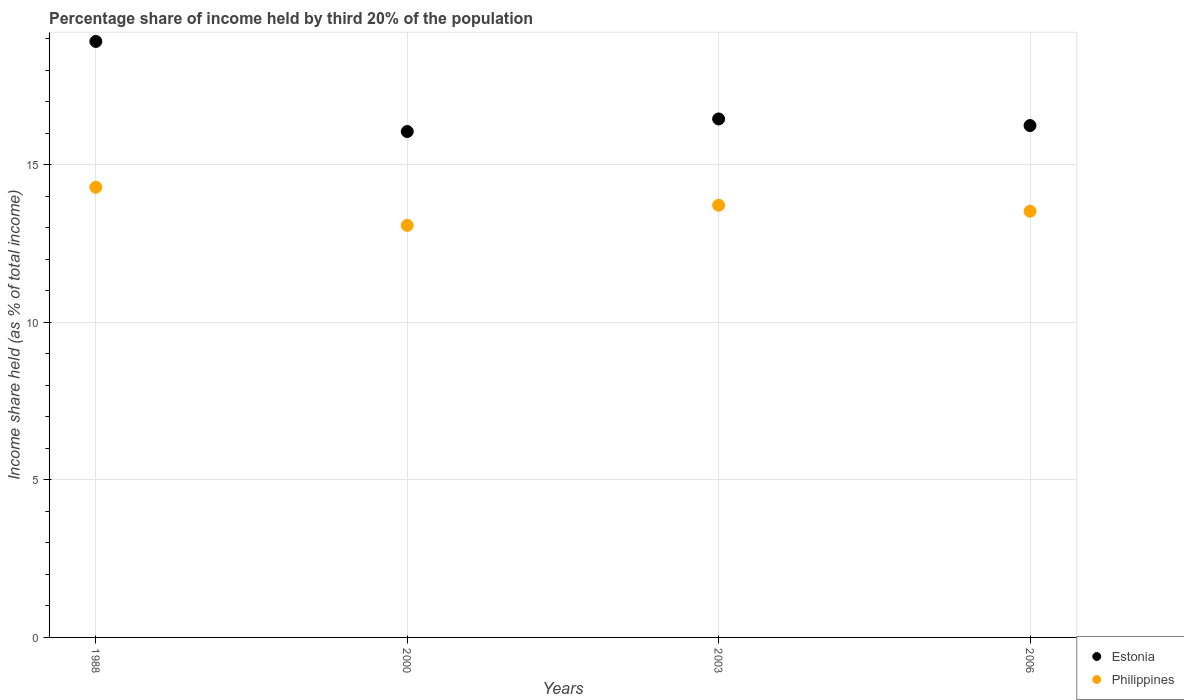How many different coloured dotlines are there?
Offer a very short reply. 2. What is the share of income held by third 20% of the population in Philippines in 2000?
Your answer should be very brief. 13.08. Across all years, what is the maximum share of income held by third 20% of the population in Philippines?
Provide a short and direct response. 14.29. Across all years, what is the minimum share of income held by third 20% of the population in Estonia?
Your answer should be compact. 16.06. In which year was the share of income held by third 20% of the population in Estonia minimum?
Offer a terse response. 2000. What is the total share of income held by third 20% of the population in Estonia in the graph?
Make the answer very short. 67.69. What is the difference between the share of income held by third 20% of the population in Philippines in 1988 and that in 2000?
Provide a short and direct response. 1.21. What is the difference between the share of income held by third 20% of the population in Philippines in 2006 and the share of income held by third 20% of the population in Estonia in 1988?
Offer a very short reply. -5.39. What is the average share of income held by third 20% of the population in Estonia per year?
Your answer should be very brief. 16.92. In the year 2003, what is the difference between the share of income held by third 20% of the population in Philippines and share of income held by third 20% of the population in Estonia?
Offer a very short reply. -2.74. What is the ratio of the share of income held by third 20% of the population in Estonia in 1988 to that in 2003?
Offer a terse response. 1.15. Is the difference between the share of income held by third 20% of the population in Philippines in 1988 and 2000 greater than the difference between the share of income held by third 20% of the population in Estonia in 1988 and 2000?
Ensure brevity in your answer.  No. What is the difference between the highest and the second highest share of income held by third 20% of the population in Estonia?
Your answer should be very brief. 2.46. What is the difference between the highest and the lowest share of income held by third 20% of the population in Philippines?
Ensure brevity in your answer.  1.21. In how many years, is the share of income held by third 20% of the population in Estonia greater than the average share of income held by third 20% of the population in Estonia taken over all years?
Your answer should be compact. 1. Is the sum of the share of income held by third 20% of the population in Estonia in 2000 and 2006 greater than the maximum share of income held by third 20% of the population in Philippines across all years?
Keep it short and to the point. Yes. Does the share of income held by third 20% of the population in Estonia monotonically increase over the years?
Provide a short and direct response. No. Is the share of income held by third 20% of the population in Philippines strictly greater than the share of income held by third 20% of the population in Estonia over the years?
Make the answer very short. No. How many years are there in the graph?
Provide a short and direct response. 4. Are the values on the major ticks of Y-axis written in scientific E-notation?
Keep it short and to the point. No. How many legend labels are there?
Provide a short and direct response. 2. How are the legend labels stacked?
Provide a short and direct response. Vertical. What is the title of the graph?
Your response must be concise. Percentage share of income held by third 20% of the population. What is the label or title of the Y-axis?
Your answer should be very brief. Income share held (as % of total income). What is the Income share held (as % of total income) of Estonia in 1988?
Your answer should be very brief. 18.92. What is the Income share held (as % of total income) in Philippines in 1988?
Keep it short and to the point. 14.29. What is the Income share held (as % of total income) of Estonia in 2000?
Your response must be concise. 16.06. What is the Income share held (as % of total income) of Philippines in 2000?
Provide a short and direct response. 13.08. What is the Income share held (as % of total income) of Estonia in 2003?
Keep it short and to the point. 16.46. What is the Income share held (as % of total income) of Philippines in 2003?
Ensure brevity in your answer.  13.72. What is the Income share held (as % of total income) in Estonia in 2006?
Provide a short and direct response. 16.25. What is the Income share held (as % of total income) of Philippines in 2006?
Keep it short and to the point. 13.53. Across all years, what is the maximum Income share held (as % of total income) of Estonia?
Give a very brief answer. 18.92. Across all years, what is the maximum Income share held (as % of total income) in Philippines?
Give a very brief answer. 14.29. Across all years, what is the minimum Income share held (as % of total income) of Estonia?
Provide a succinct answer. 16.06. Across all years, what is the minimum Income share held (as % of total income) of Philippines?
Ensure brevity in your answer.  13.08. What is the total Income share held (as % of total income) in Estonia in the graph?
Ensure brevity in your answer.  67.69. What is the total Income share held (as % of total income) in Philippines in the graph?
Offer a terse response. 54.62. What is the difference between the Income share held (as % of total income) of Estonia in 1988 and that in 2000?
Keep it short and to the point. 2.86. What is the difference between the Income share held (as % of total income) of Philippines in 1988 and that in 2000?
Your response must be concise. 1.21. What is the difference between the Income share held (as % of total income) in Estonia in 1988 and that in 2003?
Your response must be concise. 2.46. What is the difference between the Income share held (as % of total income) in Philippines in 1988 and that in 2003?
Offer a terse response. 0.57. What is the difference between the Income share held (as % of total income) in Estonia in 1988 and that in 2006?
Provide a succinct answer. 2.67. What is the difference between the Income share held (as % of total income) of Philippines in 1988 and that in 2006?
Offer a terse response. 0.76. What is the difference between the Income share held (as % of total income) in Estonia in 2000 and that in 2003?
Provide a succinct answer. -0.4. What is the difference between the Income share held (as % of total income) of Philippines in 2000 and that in 2003?
Give a very brief answer. -0.64. What is the difference between the Income share held (as % of total income) of Estonia in 2000 and that in 2006?
Keep it short and to the point. -0.19. What is the difference between the Income share held (as % of total income) of Philippines in 2000 and that in 2006?
Give a very brief answer. -0.45. What is the difference between the Income share held (as % of total income) of Estonia in 2003 and that in 2006?
Keep it short and to the point. 0.21. What is the difference between the Income share held (as % of total income) in Philippines in 2003 and that in 2006?
Ensure brevity in your answer.  0.19. What is the difference between the Income share held (as % of total income) of Estonia in 1988 and the Income share held (as % of total income) of Philippines in 2000?
Offer a terse response. 5.84. What is the difference between the Income share held (as % of total income) of Estonia in 1988 and the Income share held (as % of total income) of Philippines in 2003?
Give a very brief answer. 5.2. What is the difference between the Income share held (as % of total income) in Estonia in 1988 and the Income share held (as % of total income) in Philippines in 2006?
Offer a terse response. 5.39. What is the difference between the Income share held (as % of total income) in Estonia in 2000 and the Income share held (as % of total income) in Philippines in 2003?
Your answer should be very brief. 2.34. What is the difference between the Income share held (as % of total income) in Estonia in 2000 and the Income share held (as % of total income) in Philippines in 2006?
Offer a terse response. 2.53. What is the difference between the Income share held (as % of total income) in Estonia in 2003 and the Income share held (as % of total income) in Philippines in 2006?
Offer a very short reply. 2.93. What is the average Income share held (as % of total income) in Estonia per year?
Offer a very short reply. 16.92. What is the average Income share held (as % of total income) of Philippines per year?
Provide a short and direct response. 13.65. In the year 1988, what is the difference between the Income share held (as % of total income) in Estonia and Income share held (as % of total income) in Philippines?
Give a very brief answer. 4.63. In the year 2000, what is the difference between the Income share held (as % of total income) of Estonia and Income share held (as % of total income) of Philippines?
Your response must be concise. 2.98. In the year 2003, what is the difference between the Income share held (as % of total income) in Estonia and Income share held (as % of total income) in Philippines?
Keep it short and to the point. 2.74. In the year 2006, what is the difference between the Income share held (as % of total income) of Estonia and Income share held (as % of total income) of Philippines?
Make the answer very short. 2.72. What is the ratio of the Income share held (as % of total income) in Estonia in 1988 to that in 2000?
Give a very brief answer. 1.18. What is the ratio of the Income share held (as % of total income) of Philippines in 1988 to that in 2000?
Give a very brief answer. 1.09. What is the ratio of the Income share held (as % of total income) of Estonia in 1988 to that in 2003?
Make the answer very short. 1.15. What is the ratio of the Income share held (as % of total income) in Philippines in 1988 to that in 2003?
Make the answer very short. 1.04. What is the ratio of the Income share held (as % of total income) of Estonia in 1988 to that in 2006?
Offer a very short reply. 1.16. What is the ratio of the Income share held (as % of total income) of Philippines in 1988 to that in 2006?
Offer a terse response. 1.06. What is the ratio of the Income share held (as % of total income) in Estonia in 2000 to that in 2003?
Your answer should be compact. 0.98. What is the ratio of the Income share held (as % of total income) of Philippines in 2000 to that in 2003?
Your answer should be very brief. 0.95. What is the ratio of the Income share held (as % of total income) of Estonia in 2000 to that in 2006?
Give a very brief answer. 0.99. What is the ratio of the Income share held (as % of total income) in Philippines in 2000 to that in 2006?
Offer a very short reply. 0.97. What is the ratio of the Income share held (as % of total income) of Estonia in 2003 to that in 2006?
Offer a very short reply. 1.01. What is the difference between the highest and the second highest Income share held (as % of total income) in Estonia?
Provide a short and direct response. 2.46. What is the difference between the highest and the second highest Income share held (as % of total income) in Philippines?
Provide a short and direct response. 0.57. What is the difference between the highest and the lowest Income share held (as % of total income) of Estonia?
Your answer should be very brief. 2.86. What is the difference between the highest and the lowest Income share held (as % of total income) in Philippines?
Your answer should be very brief. 1.21. 